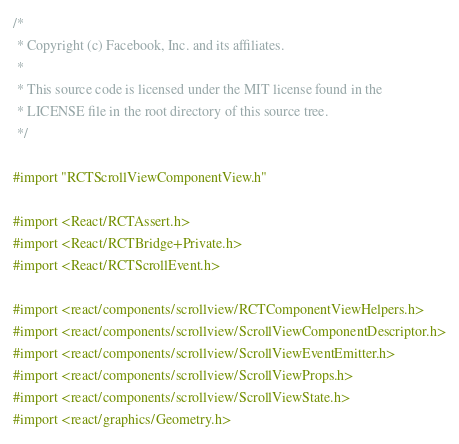Convert code to text. <code><loc_0><loc_0><loc_500><loc_500><_ObjectiveC_>/*
 * Copyright (c) Facebook, Inc. and its affiliates.
 *
 * This source code is licensed under the MIT license found in the
 * LICENSE file in the root directory of this source tree.
 */

#import "RCTScrollViewComponentView.h"

#import <React/RCTAssert.h>
#import <React/RCTBridge+Private.h>
#import <React/RCTScrollEvent.h>

#import <react/components/scrollview/RCTComponentViewHelpers.h>
#import <react/components/scrollview/ScrollViewComponentDescriptor.h>
#import <react/components/scrollview/ScrollViewEventEmitter.h>
#import <react/components/scrollview/ScrollViewProps.h>
#import <react/components/scrollview/ScrollViewState.h>
#import <react/graphics/Geometry.h>
</code> 